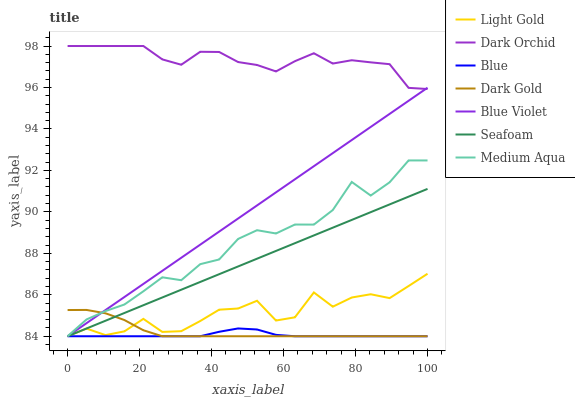Does Blue have the minimum area under the curve?
Answer yes or no. Yes. Does Dark Orchid have the maximum area under the curve?
Answer yes or no. Yes. Does Dark Gold have the minimum area under the curve?
Answer yes or no. No. Does Dark Gold have the maximum area under the curve?
Answer yes or no. No. Is Seafoam the smoothest?
Answer yes or no. Yes. Is Light Gold the roughest?
Answer yes or no. Yes. Is Dark Gold the smoothest?
Answer yes or no. No. Is Dark Gold the roughest?
Answer yes or no. No. Does Blue have the lowest value?
Answer yes or no. Yes. Does Dark Orchid have the lowest value?
Answer yes or no. No. Does Dark Orchid have the highest value?
Answer yes or no. Yes. Does Dark Gold have the highest value?
Answer yes or no. No. Is Blue less than Dark Orchid?
Answer yes or no. Yes. Is Dark Orchid greater than Medium Aqua?
Answer yes or no. Yes. Does Seafoam intersect Light Gold?
Answer yes or no. Yes. Is Seafoam less than Light Gold?
Answer yes or no. No. Is Seafoam greater than Light Gold?
Answer yes or no. No. Does Blue intersect Dark Orchid?
Answer yes or no. No. 